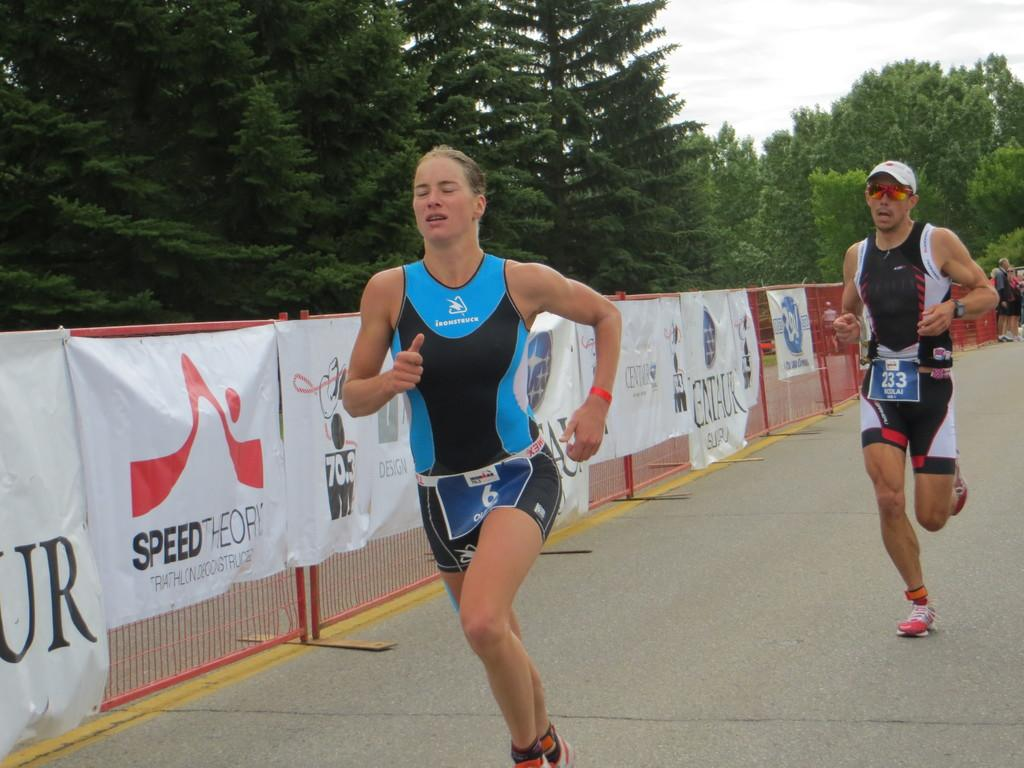<image>
Write a terse but informative summary of the picture. a couple of runners with a sign next to them that says speed 